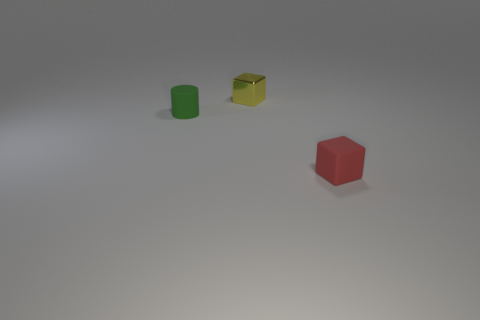What colors are the objects, and how many objects are there in total? In this image, there are three objects, each with a distinct color. We have a green cylinder, a yellow cube, and a red cube. Arranged on a flat surface, they create a simple yet striking composition. 